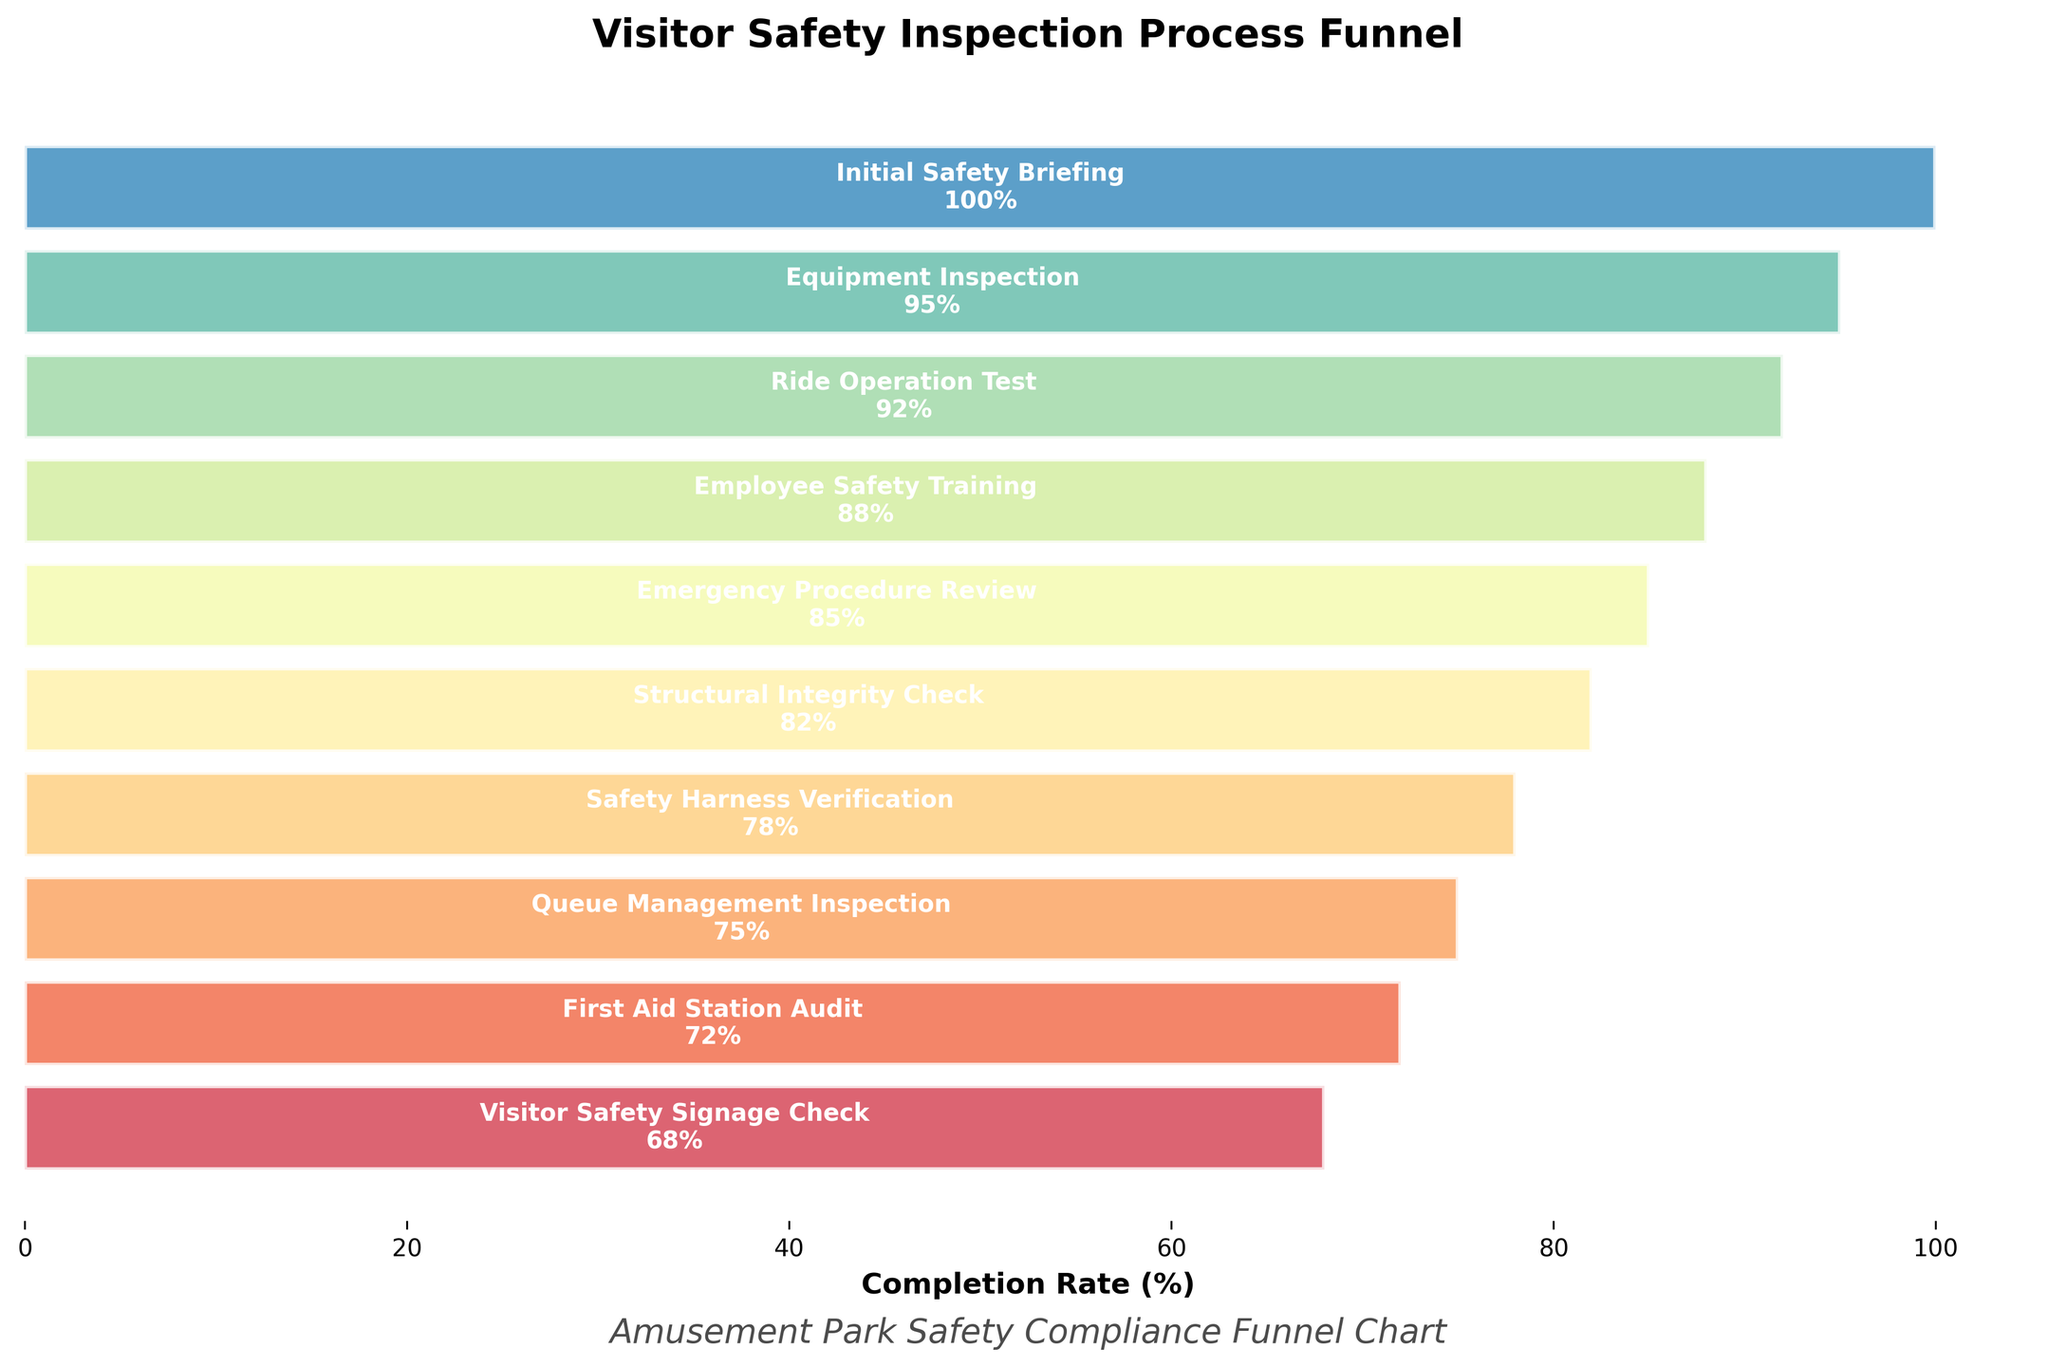What's the title of the chart? The title of the chart is generally found at the top of the figure. Here, it is written in bold and states the main idea or summary of the chart.
Answer: Visitor Safety Inspection Process Funnel What is the completion rate for the Emergency Procedure Review stage? To find the completion rate, locate the "Emergency Procedure Review" stage and then check the associated value next to this stage in the chart.
Answer: 85% Which stage has the lowest completion rate? Scan through the listed stages in the chart and identify the one with the smallest percentage completion rate value.
Answer: Visitor Safety Signage Check How many stages have a completion rate of 90% or higher? Look at all the stages at the top of the funnel that have a percentage of 90 or more.
Answer: 2 stages What is the average completion rate of the stages? Add up all the completion rates and divide by the number of stages. Specifically: (100 + 95 + 92 + 88 + 85 + 82 + 78 + 75 + 72 + 68) / 10 = 835 / 10
Answer: 83.5% Which stage's completion rate is closest to 80%? Compare the completion rates around 80% and determine which value is the nearest to 80%.
Answer: Structural Integrity Check How much percentage point difference is there between the highest and the lowest completion rates? Subtract the lowest completion rate value from the highest completion rate value. Specifically: 100 - 68.
Answer: 32 percentage points Which stage follows 'Ride Operation Test' in the funnel chart? Identify the 'Ride Operation Test' stage in the funnel and find the subsequent stage listed immediately below it.
Answer: Employee Safety Training What is the combined completion rate of 'Queue Management Inspection' and 'First Aid Station Audit'? Add the completion rates of 'Queue Management Inspection' and 'First Aid Station Audit'. Specifically: 75 + 72.
Answer: 147% Does 'Safety Harness Verification' have a higher completion rate compared to 'Emergency Procedure Review'? Compare the completion rates of 'Safety Harness Verification' and 'Emergency Procedure Review' by checking their respective values in the chart.
Answer: No 